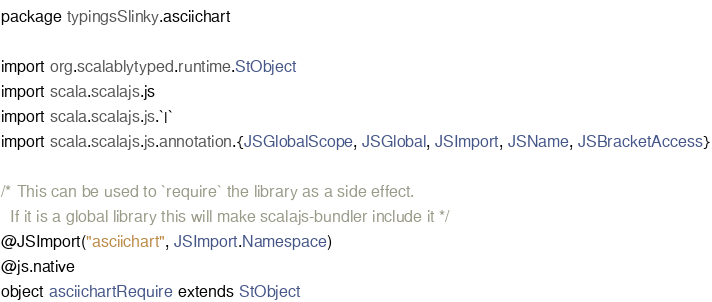<code> <loc_0><loc_0><loc_500><loc_500><_Scala_>package typingsSlinky.asciichart

import org.scalablytyped.runtime.StObject
import scala.scalajs.js
import scala.scalajs.js.`|`
import scala.scalajs.js.annotation.{JSGlobalScope, JSGlobal, JSImport, JSName, JSBracketAccess}

/* This can be used to `require` the library as a side effect.
  If it is a global library this will make scalajs-bundler include it */
@JSImport("asciichart", JSImport.Namespace)
@js.native
object asciichartRequire extends StObject
</code> 